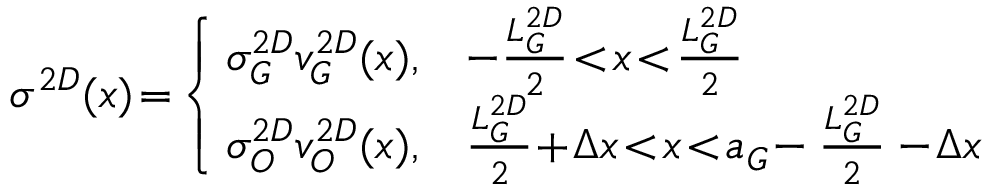Convert formula to latex. <formula><loc_0><loc_0><loc_500><loc_500>\sigma ^ { 2 D } ( x ) \, = \, \left \{ \, \begin{array} { l l } { \sigma _ { G } ^ { 2 D } v _ { G } ^ { 2 D } ( x ) , } & { - \frac { L _ { G } ^ { 2 D } } { 2 } \, < \, x \, < \, \frac { L _ { G } ^ { 2 D } } { 2 } } \\ { \sigma _ { O } ^ { 2 D } v _ { O } ^ { 2 D } ( x ) , } & { \frac { L _ { G } ^ { 2 D } } { 2 } \, + \, \Delta x \, < \, x \, < \, a _ { G } \, - \frac { L _ { G } ^ { 2 D } } { 2 } - \, \Delta x } \end{array}</formula> 